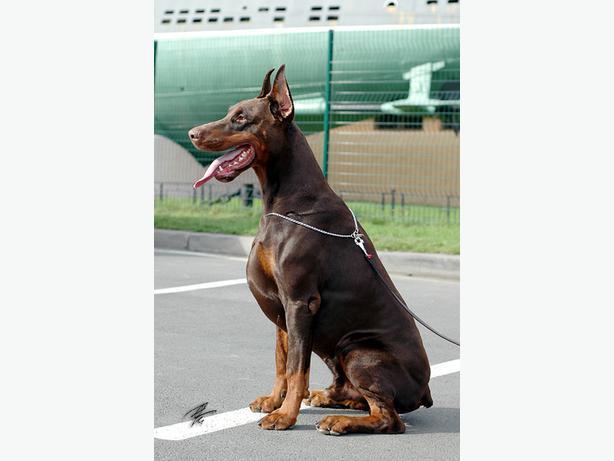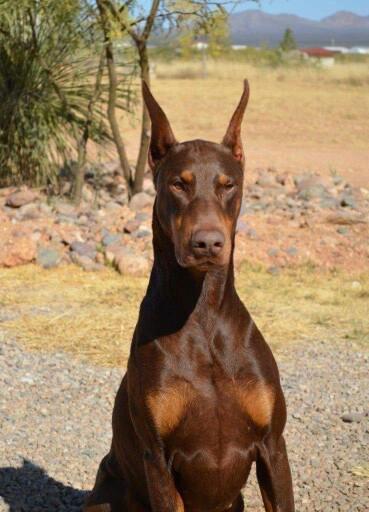The first image is the image on the left, the second image is the image on the right. Given the left and right images, does the statement "Each image contains multiple dobermans, at least one image shows dobermans in front of water, and one image shows exactly two pointy-eared dobermans side-by-side." hold true? Answer yes or no. No. The first image is the image on the left, the second image is the image on the right. For the images displayed, is the sentence "The left image contains two dogs." factually correct? Answer yes or no. No. 